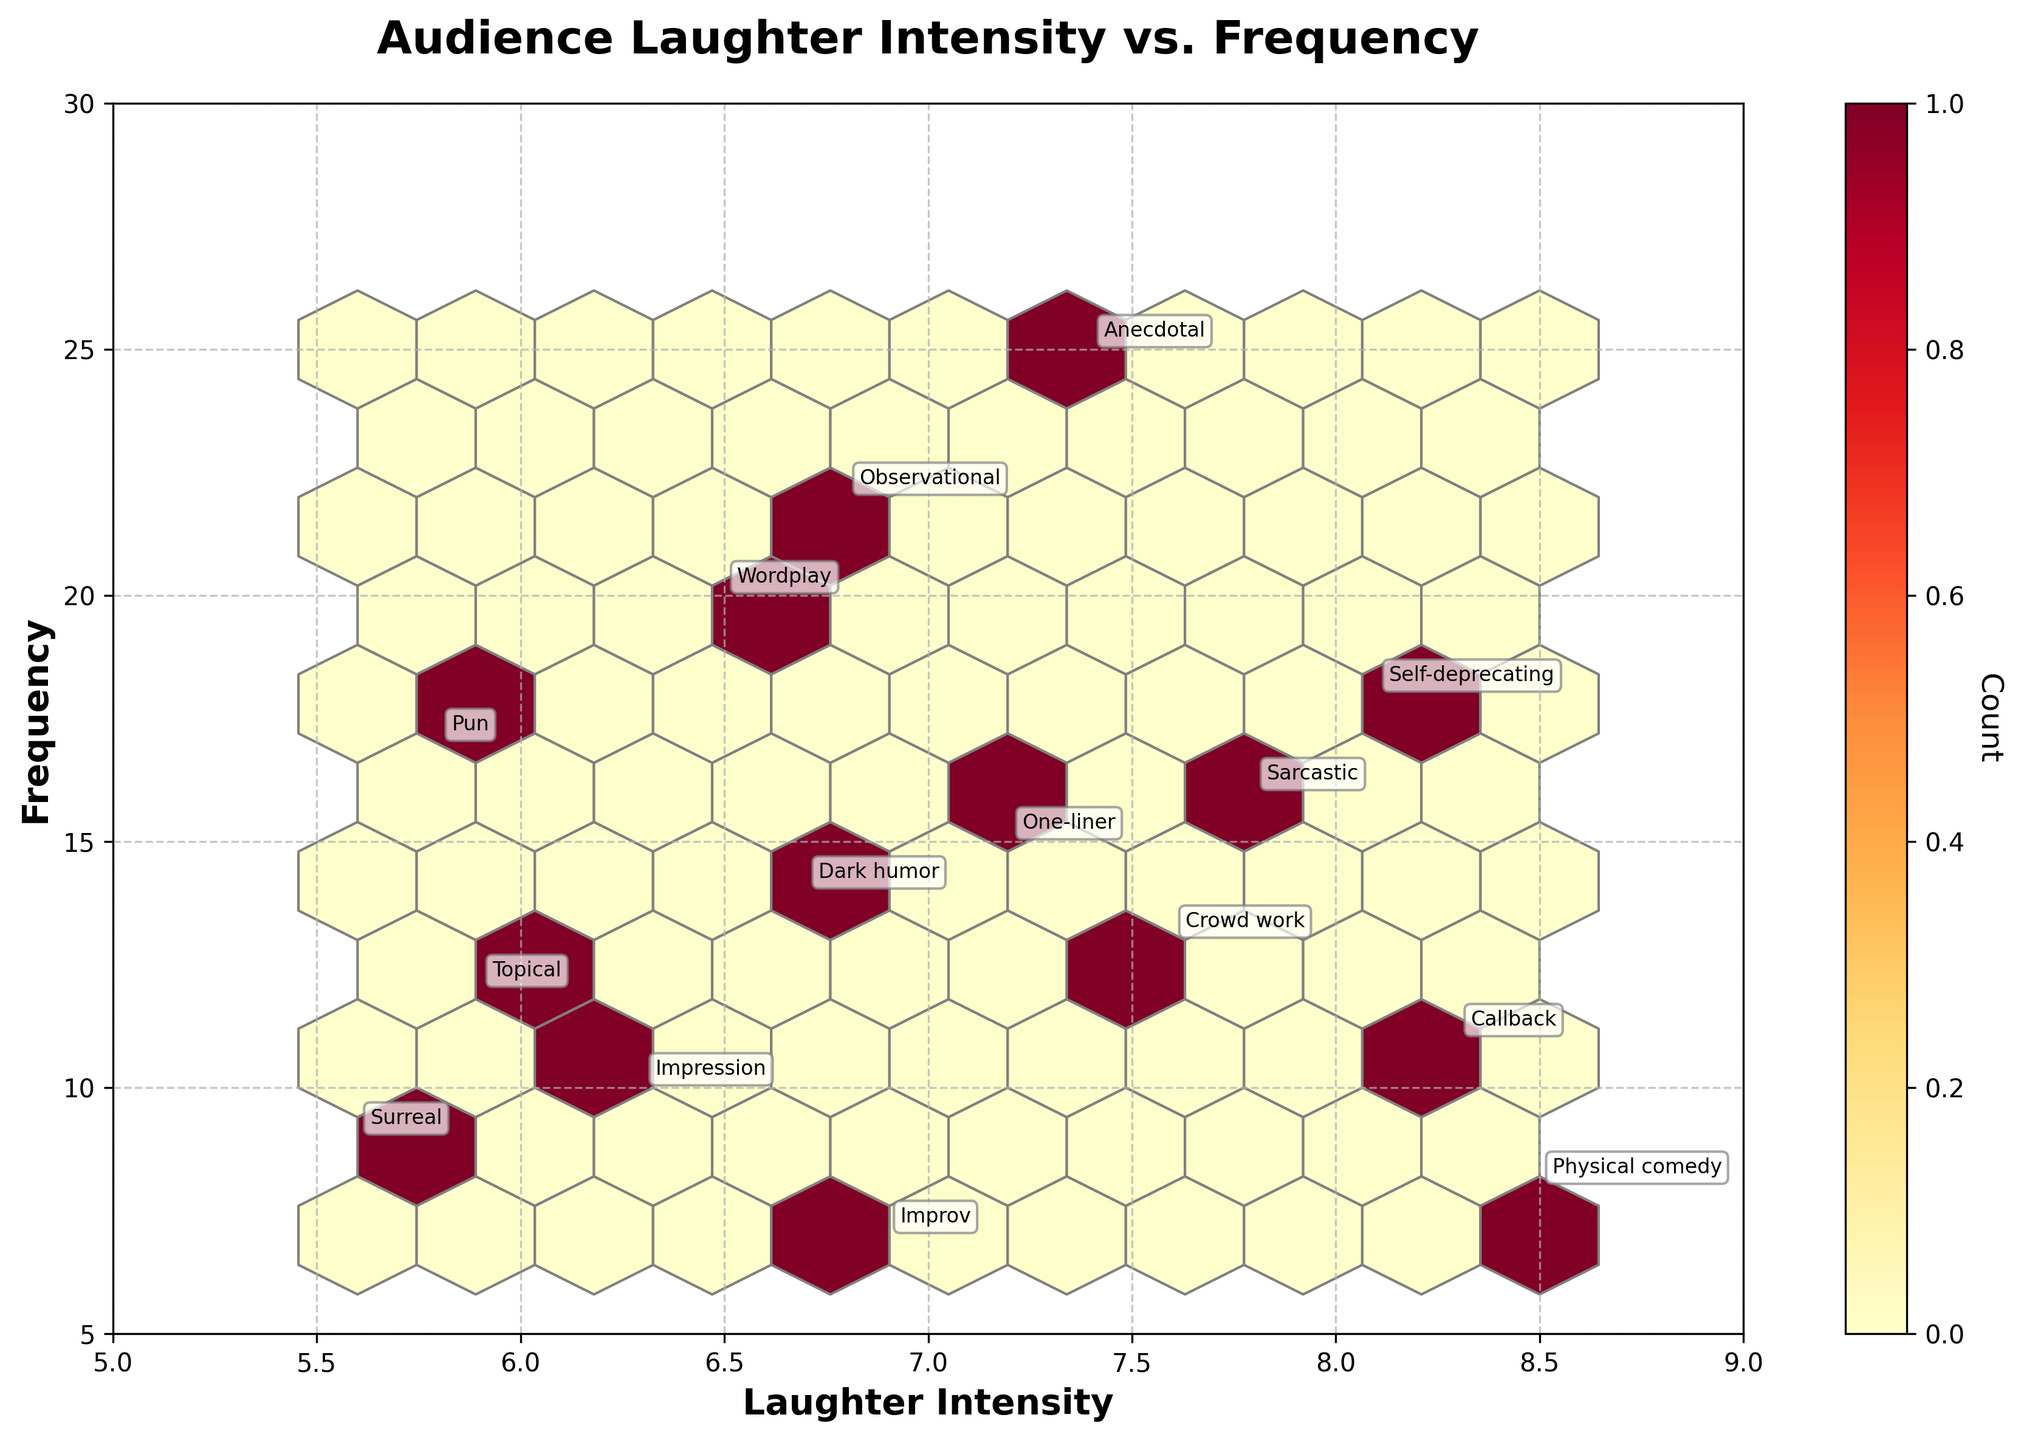What's the title of the plot? The title of a plot is usually located at the top. By looking at the figure, the title is prominently displayed as "Audience Laughter Intensity vs. Frequency".
Answer: Audience Laughter Intensity vs. Frequency What is the color scheme used in the hexbin plot? The color scheme can be observed in the hexagons and the colorbar. The plot uses shades of yellow to red, indicating the use of the 'YlOrRd' colormap.
Answer: Shades of yellow to red What are the x and y axis labels? Axis labels are generally found beside the axes. For this plot, the x-axis is labeled "Laughter Intensity" and the y-axis is labeled "Frequency".
Answer: Laughter Intensity and Frequency How many joke types have a laughter intensity greater than 8? By examining the annotations near the hexagons for a laughter intensity value greater than 8, we see that there are two joke types: "Self-deprecating" and "Physical comedy".
Answer: 2 Which joke type has the highest frequency and what is its frequency? The joke types and their frequencies can be read directly from annotations. The "Anecdotal" joke type has the highest frequency with a value of 25.
Answer: Anecdotal, 25 What is the average laughter intensity of the joke types present in the plot? To find the average, sum the laughter intensities of all joke types and then divide by the number of joke types. The sum of laughter intensities is 110.4, and there are 15 joke types. So, the average is 110.4 / 15 ≈ 7.36.
Answer: 7.36 Compare the frequencies of "One-liner" and "Wordplay" joke types. Which one has a greater frequency, and by how much? "One-liner" has a frequency of 15, and "Wordplay" has a frequency of 20. The difference in their frequencies is 20 - 15 = 5. Wordplay has a greater frequency by 5.
Answer: Wordplay, 5 How does the frequency of “Dark humor” compare to the frequency of "Pun"? The frequency of “Dark humor” can be seen as 14 and for "Pun" is 17. Therefore, “Pun” has a higher frequency than “Dark humor”.
Answer: Pun has a higher frequency Identify any two joke types with similar laughter intensities but different frequencies. By checking the annotations, "Observational" (6.8) and "Dark humor" (6.7) have similar laughter intensities but their frequencies are 22 and 14 respectively, showing a difference in frequency.
Answer: Observational and Dark humor Which area in the plot corresponds to the highest density of data points? The densest area can be identified by the darkest hexagons in the plot. The area around laughter intensities of 6.5-7.0 and frequencies of 15-20 seems to have the highest density.
Answer: Around 6.5-7.0 (Laughter Intensity) and 15-20 (Frequency) 